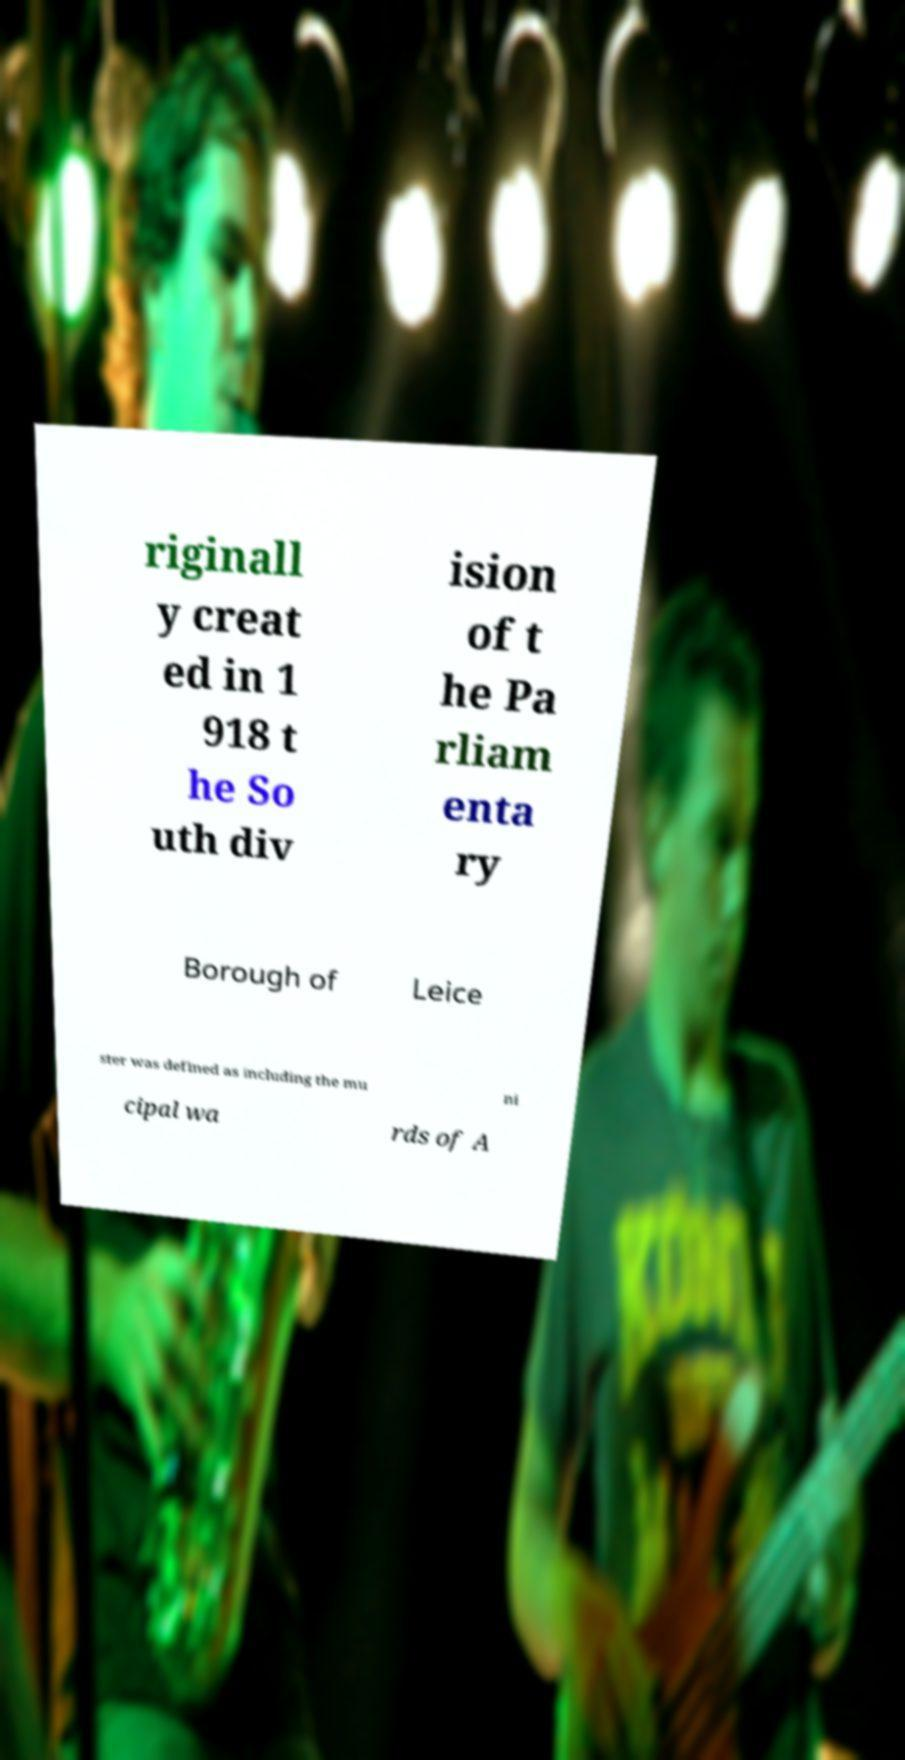I need the written content from this picture converted into text. Can you do that? riginall y creat ed in 1 918 t he So uth div ision of t he Pa rliam enta ry Borough of Leice ster was defined as including the mu ni cipal wa rds of A 